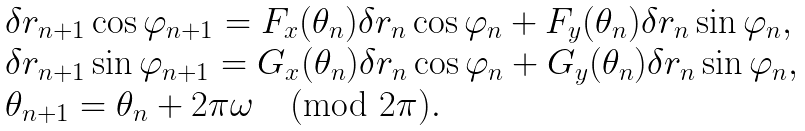<formula> <loc_0><loc_0><loc_500><loc_500>\begin{array} { l l l } \delta r _ { n + 1 } \cos { \varphi _ { n + 1 } } = F _ { x } ( \theta _ { n } ) \delta r _ { n } \cos { \varphi _ { n } } + F _ { y } ( \theta _ { n } ) \delta r _ { n } \sin { \varphi _ { n } } , \\ \delta r _ { n + 1 } \sin { \varphi _ { n + 1 } } = G _ { x } ( \theta _ { n } ) \delta r _ { n } \cos { \varphi _ { n } } + G _ { y } ( \theta _ { n } ) \delta r _ { n } \sin { \varphi _ { n } } , \\ \theta _ { n + 1 } = \theta _ { n } + 2 \pi \omega \pmod { 2 \pi } . \end{array}</formula> 